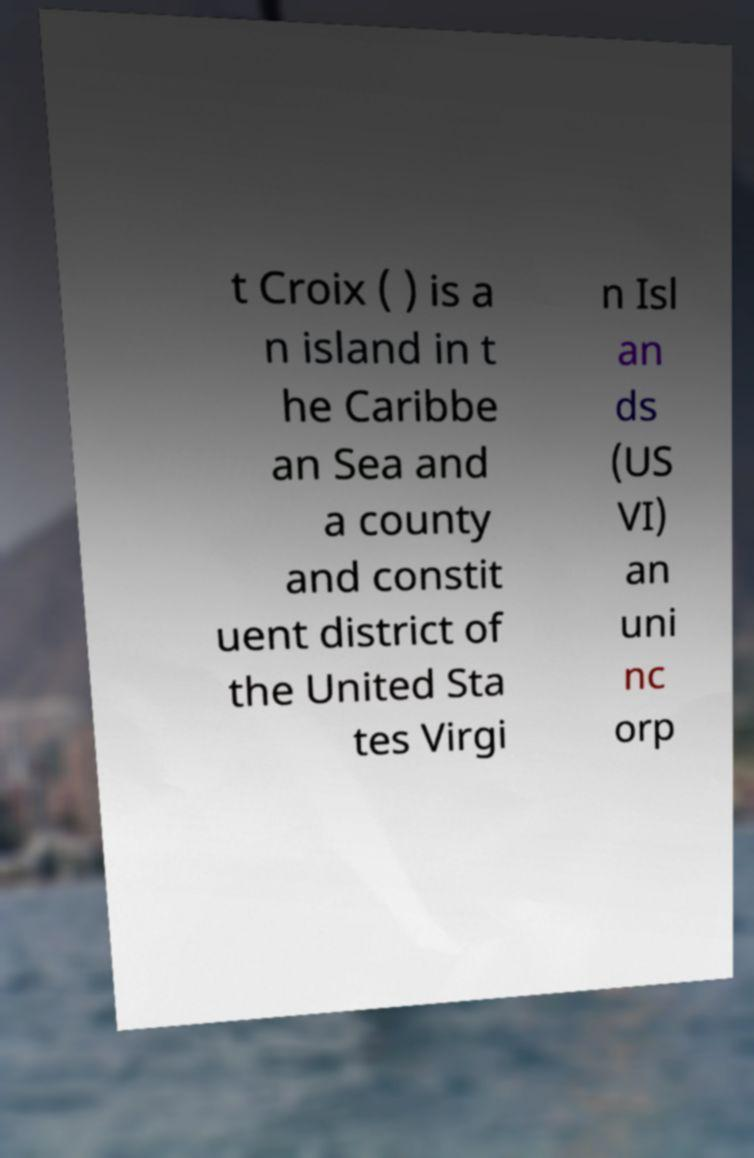Can you accurately transcribe the text from the provided image for me? t Croix ( ) is a n island in t he Caribbe an Sea and a county and constit uent district of the United Sta tes Virgi n Isl an ds (US VI) an uni nc orp 